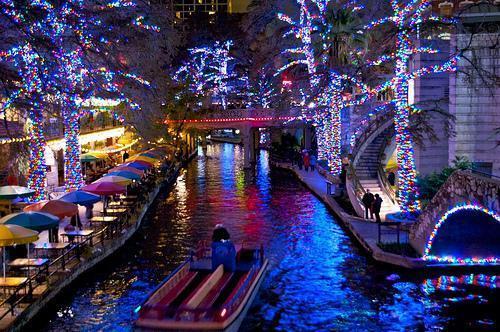How many people are near the stairs?
Give a very brief answer. 2. How many people are at the base of the stairs to the right of the boat?
Give a very brief answer. 2. 